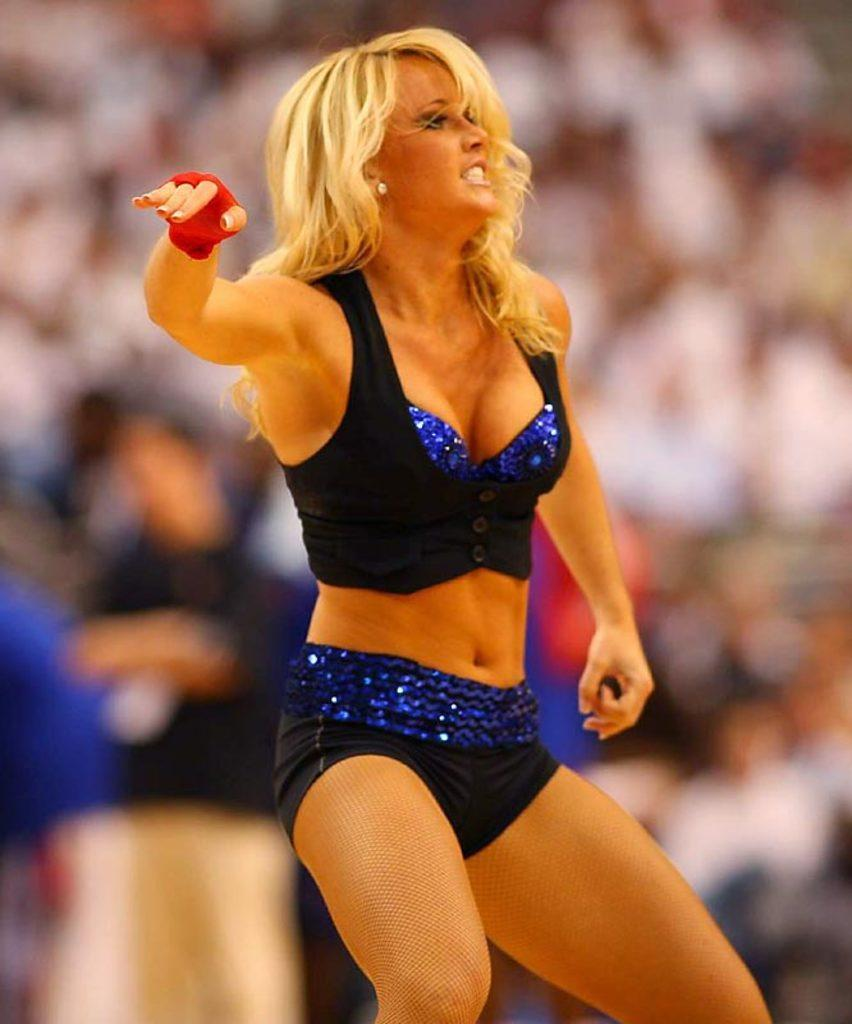Who are the main subjects in the image? There are women in the center of the image. What can be seen in the background of the image? There is a crowd in the background of the image. What month is depicted in the image? There is no specific month depicted in the image; it does not show any seasonal or time-related elements. 